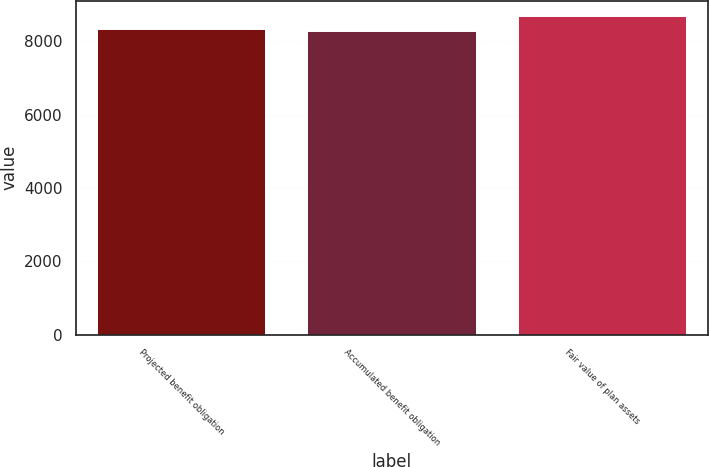<chart> <loc_0><loc_0><loc_500><loc_500><bar_chart><fcel>Projected benefit obligation<fcel>Accumulated benefit obligation<fcel>Fair value of plan assets<nl><fcel>8324.1<fcel>8285<fcel>8676<nl></chart> 